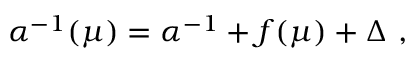<formula> <loc_0><loc_0><loc_500><loc_500>\alpha ^ { - 1 } ( \mu ) = \alpha ^ { - 1 } + f ( \mu ) + \Delta ,</formula> 